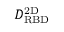Convert formula to latex. <formula><loc_0><loc_0><loc_500><loc_500>D _ { R B D } ^ { 2 D }</formula> 